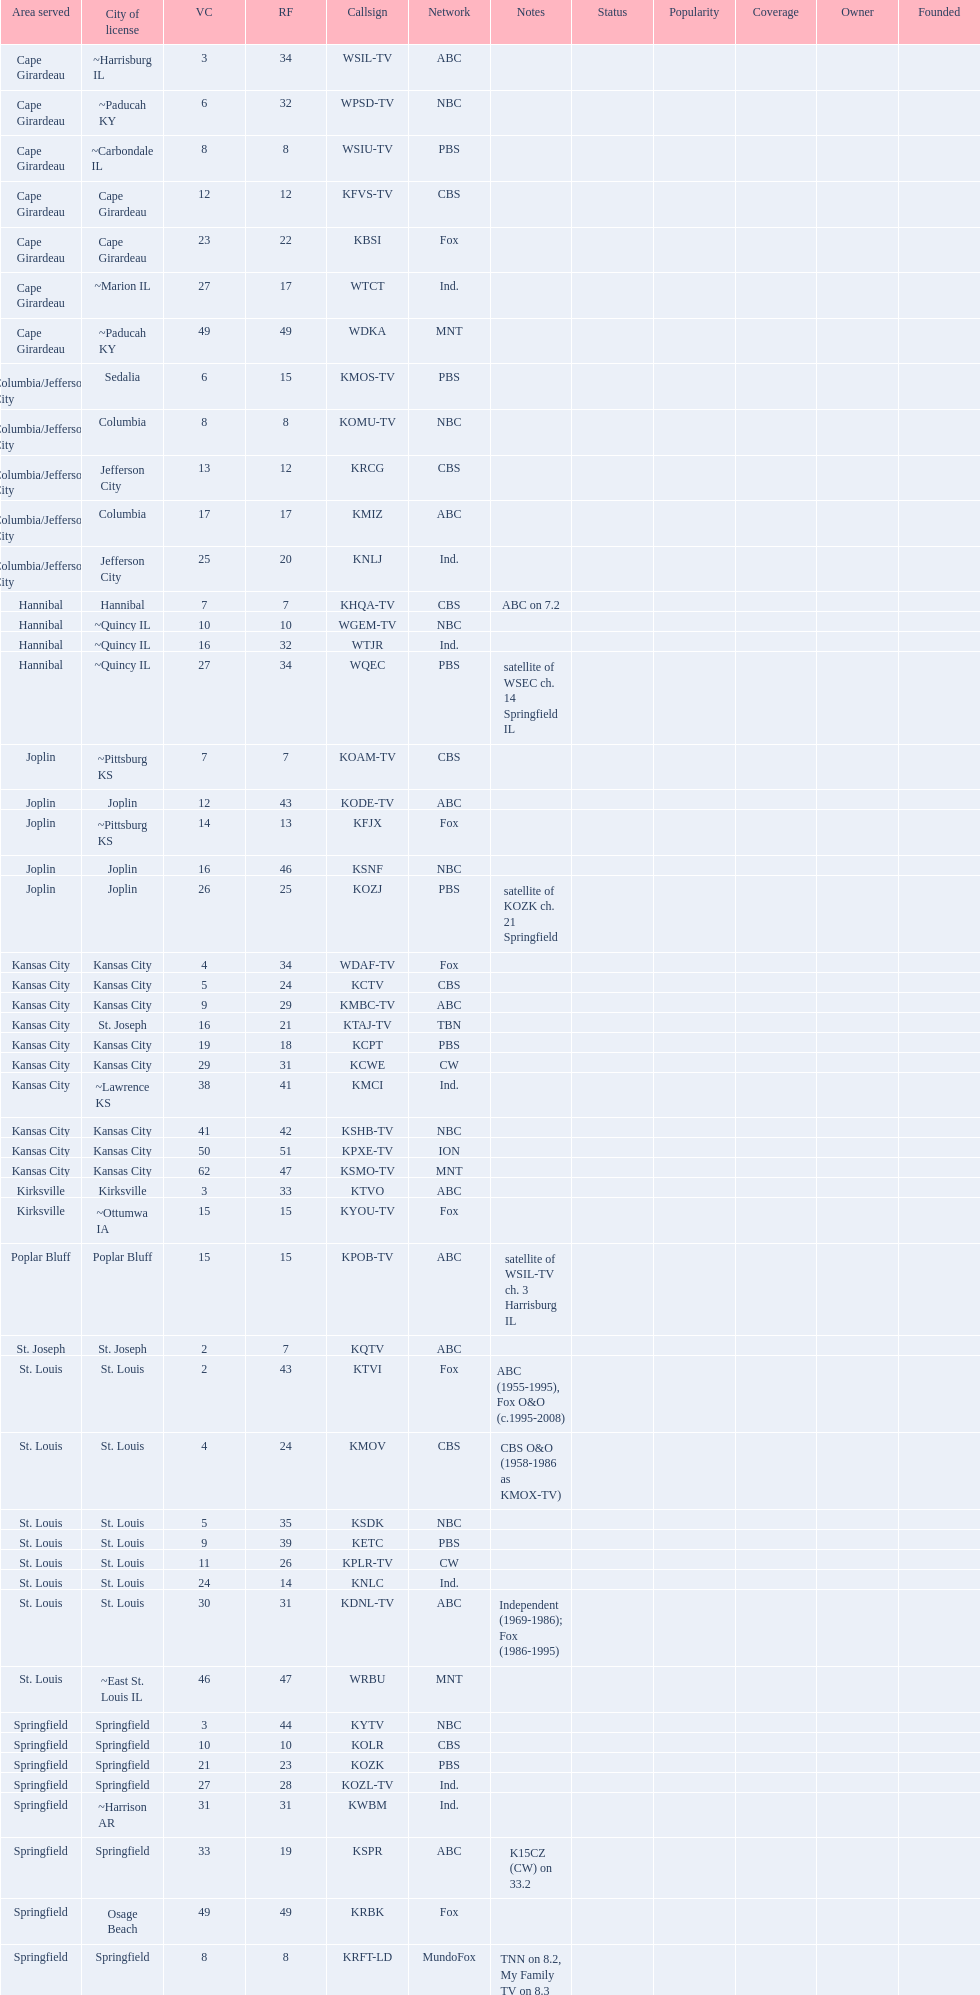Write the full table. {'header': ['Area served', 'City of license', 'VC', 'RF', 'Callsign', 'Network', 'Notes', 'Status', 'Popularity', 'Coverage', 'Owner', 'Founded'], 'rows': [['Cape Girardeau', '~Harrisburg IL', '3', '34', 'WSIL-TV', 'ABC', '', '', '', '', '', ''], ['Cape Girardeau', '~Paducah KY', '6', '32', 'WPSD-TV', 'NBC', '', '', '', '', '', ''], ['Cape Girardeau', '~Carbondale IL', '8', '8', 'WSIU-TV', 'PBS', '', '', '', '', '', ''], ['Cape Girardeau', 'Cape Girardeau', '12', '12', 'KFVS-TV', 'CBS', '', '', '', '', '', ''], ['Cape Girardeau', 'Cape Girardeau', '23', '22', 'KBSI', 'Fox', '', '', '', '', '', ''], ['Cape Girardeau', '~Marion IL', '27', '17', 'WTCT', 'Ind.', '', '', '', '', '', ''], ['Cape Girardeau', '~Paducah KY', '49', '49', 'WDKA', 'MNT', '', '', '', '', '', ''], ['Columbia/Jefferson City', 'Sedalia', '6', '15', 'KMOS-TV', 'PBS', '', '', '', '', '', ''], ['Columbia/Jefferson City', 'Columbia', '8', '8', 'KOMU-TV', 'NBC', '', '', '', '', '', ''], ['Columbia/Jefferson City', 'Jefferson City', '13', '12', 'KRCG', 'CBS', '', '', '', '', '', ''], ['Columbia/Jefferson City', 'Columbia', '17', '17', 'KMIZ', 'ABC', '', '', '', '', '', ''], ['Columbia/Jefferson City', 'Jefferson City', '25', '20', 'KNLJ', 'Ind.', '', '', '', '', '', ''], ['Hannibal', 'Hannibal', '7', '7', 'KHQA-TV', 'CBS', 'ABC on 7.2', '', '', '', '', ''], ['Hannibal', '~Quincy IL', '10', '10', 'WGEM-TV', 'NBC', '', '', '', '', '', ''], ['Hannibal', '~Quincy IL', '16', '32', 'WTJR', 'Ind.', '', '', '', '', '', ''], ['Hannibal', '~Quincy IL', '27', '34', 'WQEC', 'PBS', 'satellite of WSEC ch. 14 Springfield IL', '', '', '', '', ''], ['Joplin', '~Pittsburg KS', '7', '7', 'KOAM-TV', 'CBS', '', '', '', '', '', ''], ['Joplin', 'Joplin', '12', '43', 'KODE-TV', 'ABC', '', '', '', '', '', ''], ['Joplin', '~Pittsburg KS', '14', '13', 'KFJX', 'Fox', '', '', '', '', '', ''], ['Joplin', 'Joplin', '16', '46', 'KSNF', 'NBC', '', '', '', '', '', ''], ['Joplin', 'Joplin', '26', '25', 'KOZJ', 'PBS', 'satellite of KOZK ch. 21 Springfield', '', '', '', '', ''], ['Kansas City', 'Kansas City', '4', '34', 'WDAF-TV', 'Fox', '', '', '', '', '', ''], ['Kansas City', 'Kansas City', '5', '24', 'KCTV', 'CBS', '', '', '', '', '', ''], ['Kansas City', 'Kansas City', '9', '29', 'KMBC-TV', 'ABC', '', '', '', '', '', ''], ['Kansas City', 'St. Joseph', '16', '21', 'KTAJ-TV', 'TBN', '', '', '', '', '', ''], ['Kansas City', 'Kansas City', '19', '18', 'KCPT', 'PBS', '', '', '', '', '', ''], ['Kansas City', 'Kansas City', '29', '31', 'KCWE', 'CW', '', '', '', '', '', ''], ['Kansas City', '~Lawrence KS', '38', '41', 'KMCI', 'Ind.', '', '', '', '', '', ''], ['Kansas City', 'Kansas City', '41', '42', 'KSHB-TV', 'NBC', '', '', '', '', '', ''], ['Kansas City', 'Kansas City', '50', '51', 'KPXE-TV', 'ION', '', '', '', '', '', ''], ['Kansas City', 'Kansas City', '62', '47', 'KSMO-TV', 'MNT', '', '', '', '', '', ''], ['Kirksville', 'Kirksville', '3', '33', 'KTVO', 'ABC', '', '', '', '', '', ''], ['Kirksville', '~Ottumwa IA', '15', '15', 'KYOU-TV', 'Fox', '', '', '', '', '', ''], ['Poplar Bluff', 'Poplar Bluff', '15', '15', 'KPOB-TV', 'ABC', 'satellite of WSIL-TV ch. 3 Harrisburg IL', '', '', '', '', ''], ['St. Joseph', 'St. Joseph', '2', '7', 'KQTV', 'ABC', '', '', '', '', '', ''], ['St. Louis', 'St. Louis', '2', '43', 'KTVI', 'Fox', 'ABC (1955-1995), Fox O&O (c.1995-2008)', '', '', '', '', ''], ['St. Louis', 'St. Louis', '4', '24', 'KMOV', 'CBS', 'CBS O&O (1958-1986 as KMOX-TV)', '', '', '', '', ''], ['St. Louis', 'St. Louis', '5', '35', 'KSDK', 'NBC', '', '', '', '', '', ''], ['St. Louis', 'St. Louis', '9', '39', 'KETC', 'PBS', '', '', '', '', '', ''], ['St. Louis', 'St. Louis', '11', '26', 'KPLR-TV', 'CW', '', '', '', '', '', ''], ['St. Louis', 'St. Louis', '24', '14', 'KNLC', 'Ind.', '', '', '', '', '', ''], ['St. Louis', 'St. Louis', '30', '31', 'KDNL-TV', 'ABC', 'Independent (1969-1986); Fox (1986-1995)', '', '', '', '', ''], ['St. Louis', '~East St. Louis IL', '46', '47', 'WRBU', 'MNT', '', '', '', '', '', ''], ['Springfield', 'Springfield', '3', '44', 'KYTV', 'NBC', '', '', '', '', '', ''], ['Springfield', 'Springfield', '10', '10', 'KOLR', 'CBS', '', '', '', '', '', ''], ['Springfield', 'Springfield', '21', '23', 'KOZK', 'PBS', '', '', '', '', '', ''], ['Springfield', 'Springfield', '27', '28', 'KOZL-TV', 'Ind.', '', '', '', '', '', ''], ['Springfield', '~Harrison AR', '31', '31', 'KWBM', 'Ind.', '', '', '', '', '', ''], ['Springfield', 'Springfield', '33', '19', 'KSPR', 'ABC', 'K15CZ (CW) on 33.2', '', '', '', '', ''], ['Springfield', 'Osage Beach', '49', '49', 'KRBK', 'Fox', '', '', '', '', '', ''], ['Springfield', 'Springfield', '8', '8', 'KRFT-LD', 'MundoFox', 'TNN on 8.2, My Family TV on 8.3', '', '', '', '', '']]} What is the total number of stations under the cbs network? 7. 